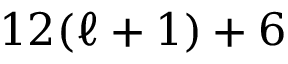<formula> <loc_0><loc_0><loc_500><loc_500>1 2 ( \ell + 1 ) + 6</formula> 